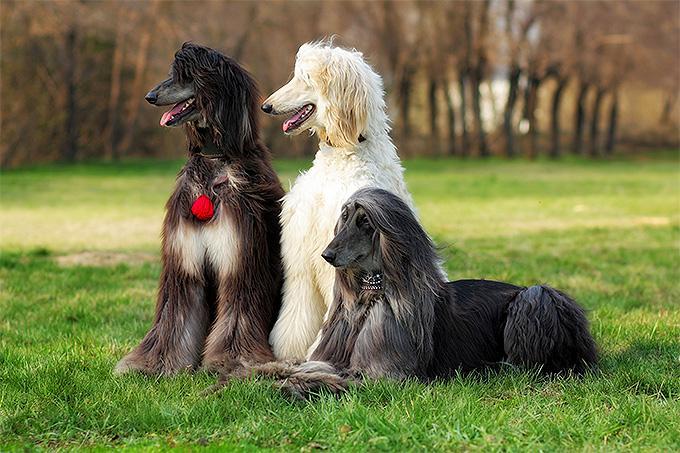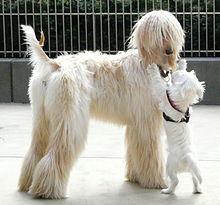The first image is the image on the left, the second image is the image on the right. Analyze the images presented: Is the assertion "There are back and cream colored dogs" valid? Answer yes or no. Yes. The first image is the image on the left, the second image is the image on the right. Evaluate the accuracy of this statement regarding the images: "There is at least one dog sitting in the image on the left". Is it true? Answer yes or no. Yes. The first image is the image on the left, the second image is the image on the right. For the images shown, is this caption "There is a headshot of a long haired dog." true? Answer yes or no. No. The first image is the image on the left, the second image is the image on the right. Considering the images on both sides, is "One image is a standing dog and one is a dog's head." valid? Answer yes or no. No. 